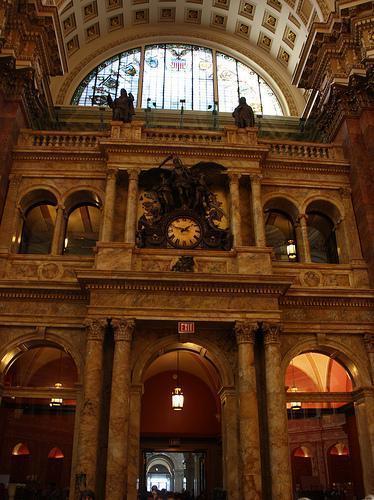How many clocks are there?
Give a very brief answer. 1. 